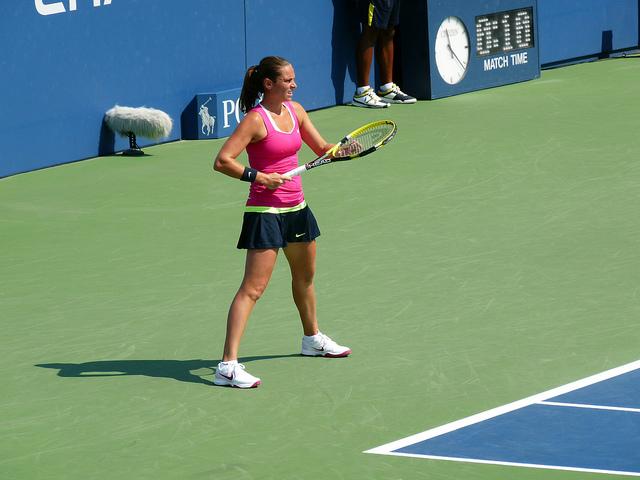What color is the woman's shirt?
Quick response, please. Pink. What color is her outfit?
Short answer required. Pink and black. Is this person about to hit the ball?
Short answer required. No. How many seconds are on the clock?
Write a very short answer. 10. Why is the young man in green shirt and white shorts have his back foot off the ground?
Write a very short answer. No man. Is the lady swing?
Short answer required. No. What color is the lady's skirt?
Keep it brief. Blue. How much time is left?
Give a very brief answer. 10 seconds. What game are they playing?
Keep it brief. Tennis. 